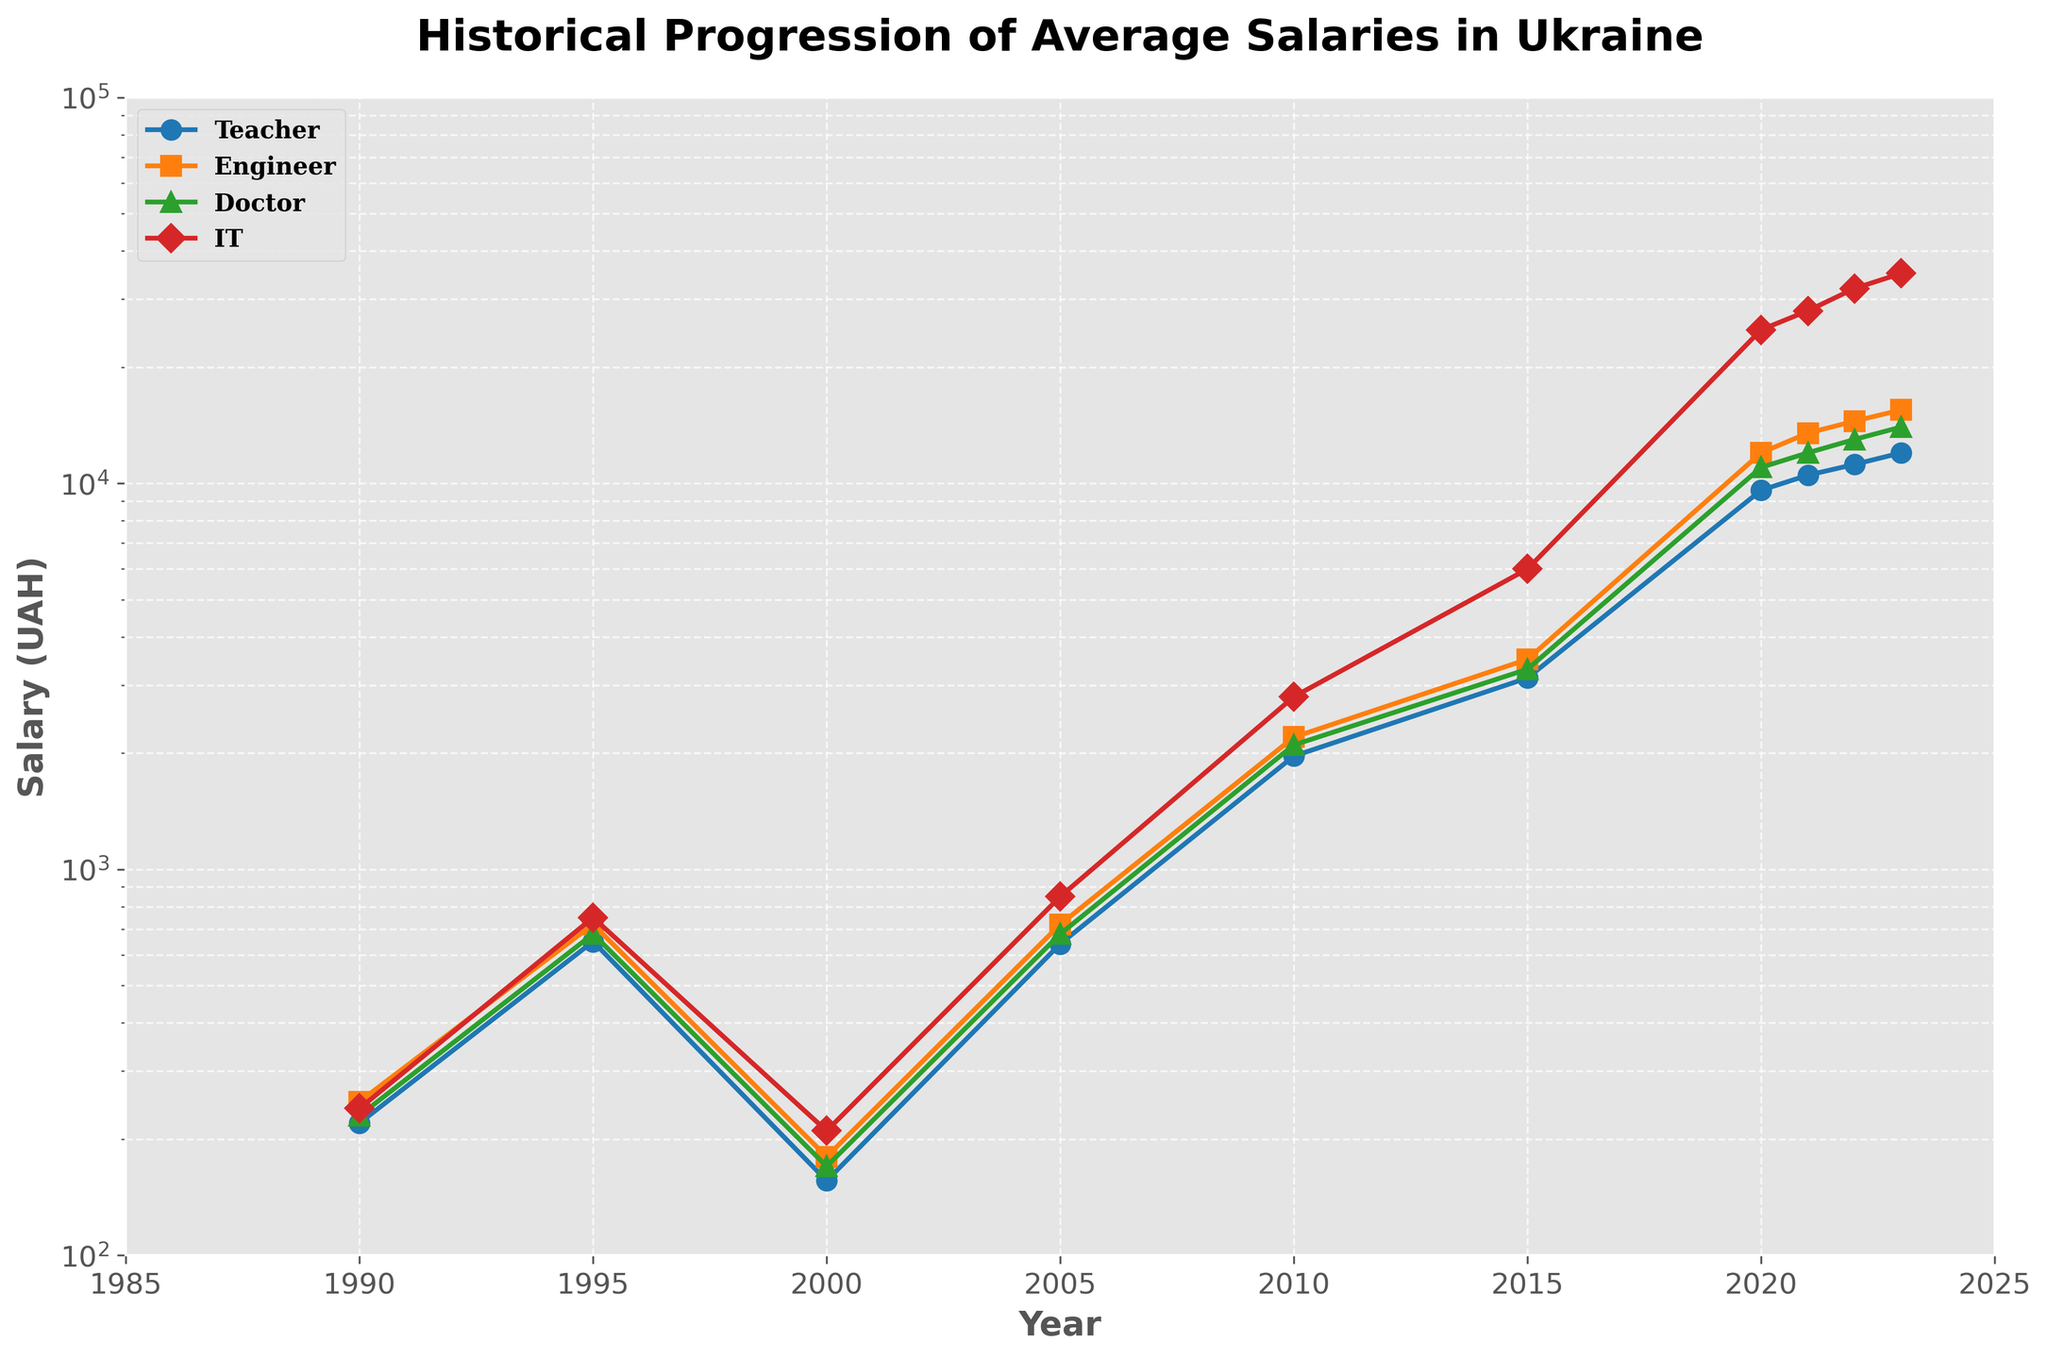What is the overall trend in teacher salaries from 1990 to 2023? The teacher salaries follow an upward trend from 1990 to 2023. Initially, there's a slow increase from 1990 to 2005, followed by a steeper rise from 2010 onwards until 2023.
Answer: Upward trend By what factor did IT Specialist salaries increase from 1990 to 2023? In 1990, IT Specialist salaries were 240 UAH, and in 2023, they were 35,000 UAH. The factor of increase is 35,000 / 240 = 145.83.
Answer: 145.83 Which profession had the highest salary in 2023, and what was the value? IT Specialists had the highest salary in 2023 with a value of 35,000 UAH.
Answer: IT Specialists, 35,000 UAH In which year did teacher salaries first exceed 10,000 UAH? Teacher salaries first exceeded 10,000 UAH in the year 2021, where they reached 10,500 UAH.
Answer: 2021 Compare the salaries of doctors and teachers in 2020. By how much did the doctor's salaries exceed that of teachers? In 2020, doctor's salaries were 11,000 UAH, and teacher's salaries were 9,600 UAH. The difference is 11,000 - 9,600 = 1,400 UAH.
Answer: 1,400 UAH What is the trend observed for IT Specialist salaries between 2010 and 2023? IT Specialist salaries show a significant upward trend between 2010 and 2023, increasing from 2,800 UAH to 35,000 UAH.
Answer: Upward trend Which year saw the largest salary gap between teachers and engineers? What was the gap? The largest salary gap between teachers and engineers occurred in 2023. Teacher salaries were 12,000 UAH, and engineer salaries were 15,500 UAH, resulting in a gap of 15,500 - 12,000 = 3,500 UAH.
Answer: 2023, 3,500 UAH By how much did teacher salaries increase from 2015 to 2023? Teacher salaries increased from 3,132 UAH in 2015 to 12,000 UAH in 2023. The increase is 12,000 - 3,132 = 8,868 UAH.
Answer: 8,868 UAH In 1995, which profession had the highest salary and which had the lowest? In 1995, IT Specialists had the highest salary at 750 UAH, while teachers had the lowest at 650 UAH.
Answer: IT Specialists, Teachers In which year did teacher salaries see their largest year-on-year increase? Teacher salaries saw their largest year-on-year increase from 2015 (3,132 UAH) to 2020 (9,600 UAH), amounting to an increase of 9,600 - 3,132 = 6,468 UAH.
Answer: 2015 to 2020 